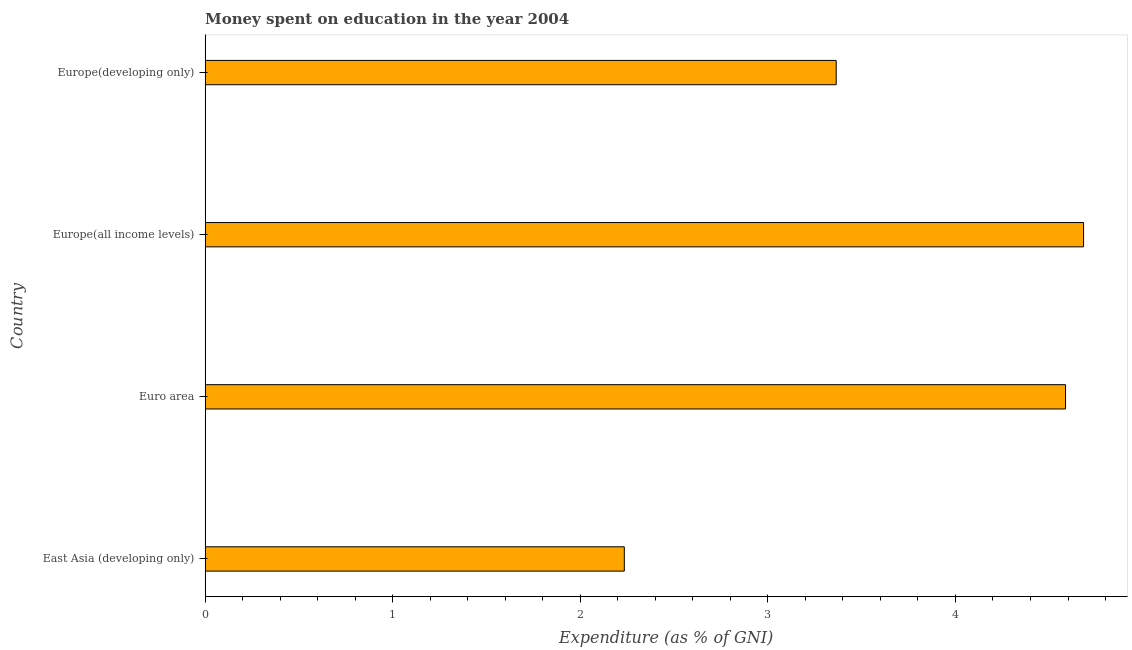Does the graph contain any zero values?
Offer a very short reply. No. What is the title of the graph?
Keep it short and to the point. Money spent on education in the year 2004. What is the label or title of the X-axis?
Give a very brief answer. Expenditure (as % of GNI). What is the label or title of the Y-axis?
Offer a terse response. Country. What is the expenditure on education in Europe(developing only)?
Offer a very short reply. 3.36. Across all countries, what is the maximum expenditure on education?
Provide a succinct answer. 4.68. Across all countries, what is the minimum expenditure on education?
Your response must be concise. 2.23. In which country was the expenditure on education maximum?
Keep it short and to the point. Europe(all income levels). In which country was the expenditure on education minimum?
Offer a very short reply. East Asia (developing only). What is the sum of the expenditure on education?
Keep it short and to the point. 14.87. What is the difference between the expenditure on education in East Asia (developing only) and Euro area?
Make the answer very short. -2.35. What is the average expenditure on education per country?
Give a very brief answer. 3.72. What is the median expenditure on education?
Make the answer very short. 3.98. In how many countries, is the expenditure on education greater than 2.4 %?
Keep it short and to the point. 3. What is the ratio of the expenditure on education in East Asia (developing only) to that in Europe(developing only)?
Your answer should be very brief. 0.66. Is the expenditure on education in Europe(all income levels) less than that in Europe(developing only)?
Give a very brief answer. No. What is the difference between the highest and the second highest expenditure on education?
Offer a very short reply. 0.1. What is the difference between the highest and the lowest expenditure on education?
Keep it short and to the point. 2.45. In how many countries, is the expenditure on education greater than the average expenditure on education taken over all countries?
Provide a succinct answer. 2. How many countries are there in the graph?
Your answer should be very brief. 4. Are the values on the major ticks of X-axis written in scientific E-notation?
Offer a terse response. No. What is the Expenditure (as % of GNI) in East Asia (developing only)?
Give a very brief answer. 2.23. What is the Expenditure (as % of GNI) in Euro area?
Keep it short and to the point. 4.59. What is the Expenditure (as % of GNI) in Europe(all income levels)?
Your answer should be very brief. 4.68. What is the Expenditure (as % of GNI) of Europe(developing only)?
Your answer should be very brief. 3.36. What is the difference between the Expenditure (as % of GNI) in East Asia (developing only) and Euro area?
Give a very brief answer. -2.35. What is the difference between the Expenditure (as % of GNI) in East Asia (developing only) and Europe(all income levels)?
Give a very brief answer. -2.45. What is the difference between the Expenditure (as % of GNI) in East Asia (developing only) and Europe(developing only)?
Your answer should be very brief. -1.13. What is the difference between the Expenditure (as % of GNI) in Euro area and Europe(all income levels)?
Your response must be concise. -0.1. What is the difference between the Expenditure (as % of GNI) in Euro area and Europe(developing only)?
Give a very brief answer. 1.22. What is the difference between the Expenditure (as % of GNI) in Europe(all income levels) and Europe(developing only)?
Provide a succinct answer. 1.32. What is the ratio of the Expenditure (as % of GNI) in East Asia (developing only) to that in Euro area?
Provide a succinct answer. 0.49. What is the ratio of the Expenditure (as % of GNI) in East Asia (developing only) to that in Europe(all income levels)?
Provide a succinct answer. 0.48. What is the ratio of the Expenditure (as % of GNI) in East Asia (developing only) to that in Europe(developing only)?
Provide a succinct answer. 0.66. What is the ratio of the Expenditure (as % of GNI) in Euro area to that in Europe(developing only)?
Your answer should be compact. 1.36. What is the ratio of the Expenditure (as % of GNI) in Europe(all income levels) to that in Europe(developing only)?
Offer a terse response. 1.39. 